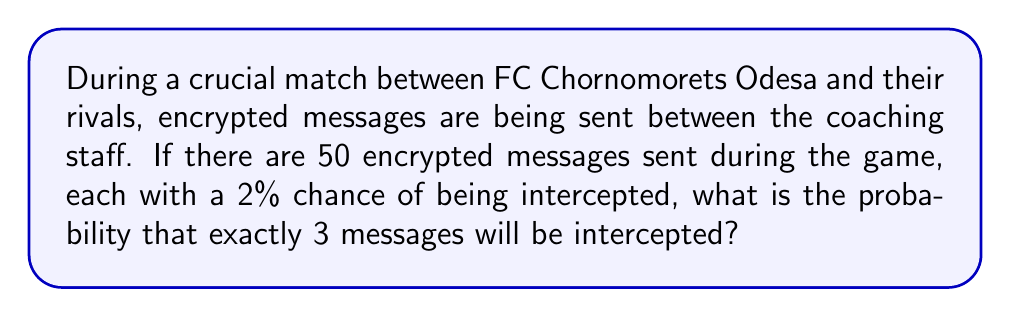What is the answer to this math problem? To solve this problem, we need to use the Binomial Probability Distribution, as we have a fixed number of independent trials (messages) with a constant probability of success (interception).

1. Let's define our variables:
   $n = 50$ (total number of messages)
   $k = 3$ (number of successful interceptions we're interested in)
   $p = 0.02$ (probability of a single message being intercepted)
   $q = 1 - p = 0.98$ (probability of a single message not being intercepted)

2. The Binomial Probability formula is:

   $$P(X = k) = \binom{n}{k} p^k q^{n-k}$$

3. Let's calculate each part:
   
   a) $\binom{n}{k} = \binom{50}{3} = \frac{50!}{3!(50-3)!} = 19,600$
   
   b) $p^k = 0.02^3 = 0.000008$
   
   c) $q^{n-k} = 0.98^{47} \approx 0.3868$

4. Now, let's put it all together:

   $$P(X = 3) = 19,600 \times 0.000008 \times 0.3868 \approx 0.0607$$

5. Convert to percentage: $0.0607 \times 100\% = 6.07\%$

Therefore, the probability of exactly 3 messages being intercepted is approximately 6.07%.
Answer: 6.07% 